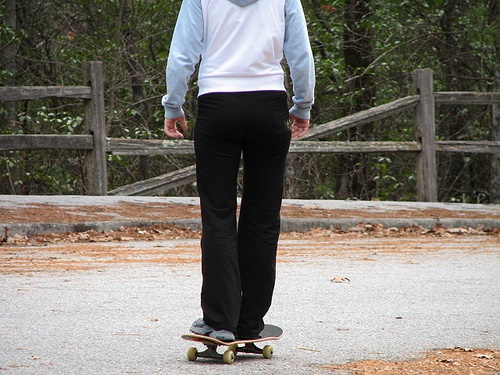Describe the objects in this image and their specific colors. I can see people in black, lavender, and darkgray tones and skateboard in black, gray, lightgray, and olive tones in this image. 